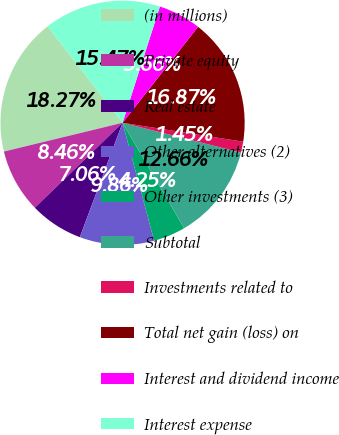Convert chart to OTSL. <chart><loc_0><loc_0><loc_500><loc_500><pie_chart><fcel>(in millions)<fcel>Private equity<fcel>Real estate<fcel>Other alternatives (2)<fcel>Other investments (3)<fcel>Subtotal<fcel>Investments related to<fcel>Total net gain (loss) on<fcel>Interest and dividend income<fcel>Interest expense<nl><fcel>18.27%<fcel>8.46%<fcel>7.06%<fcel>9.86%<fcel>4.25%<fcel>12.66%<fcel>1.45%<fcel>16.87%<fcel>5.66%<fcel>15.47%<nl></chart> 